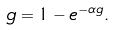Convert formula to latex. <formula><loc_0><loc_0><loc_500><loc_500>g = 1 - e ^ { - \alpha g } .</formula> 